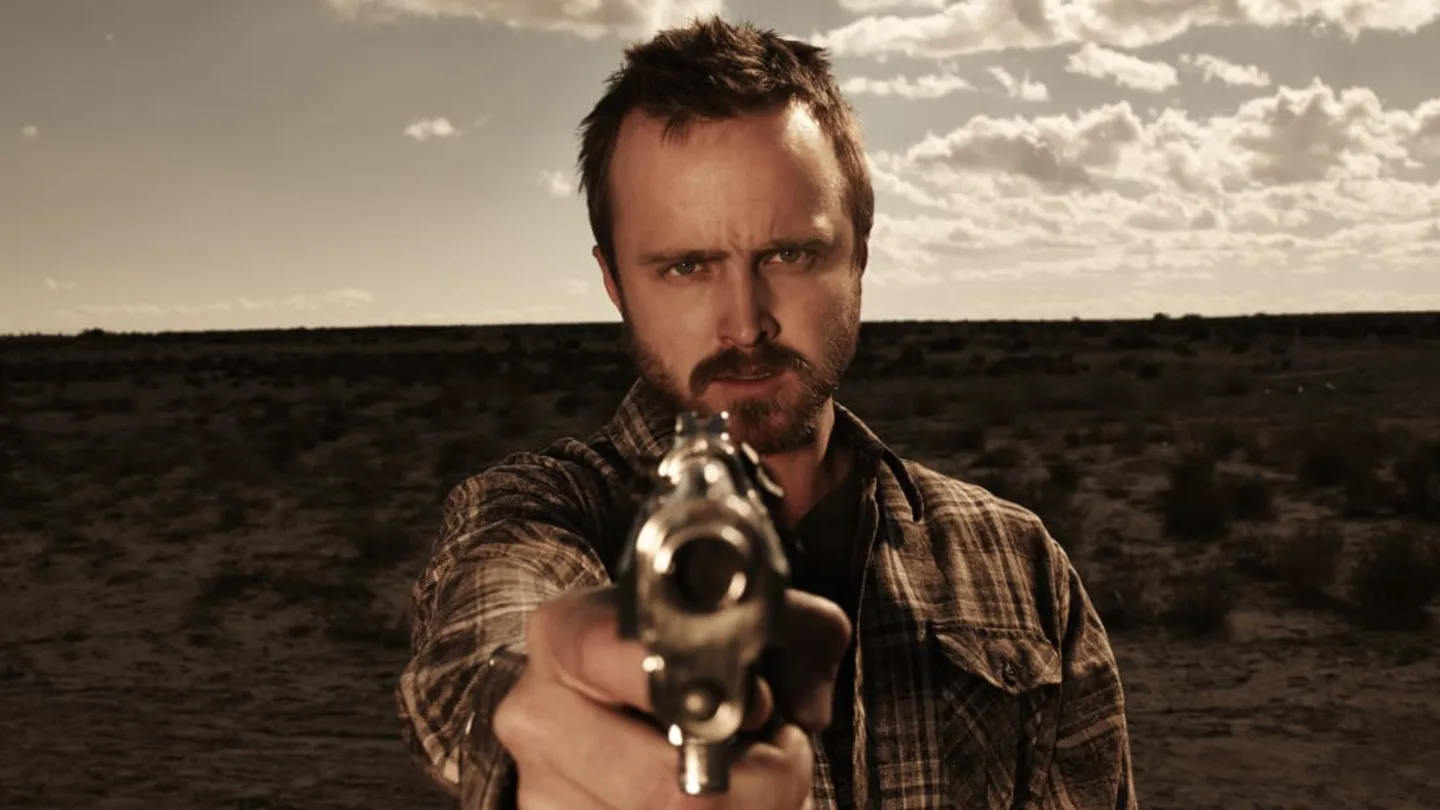What might be the significance of the desert setting in this image? The desert setting in the image might symbolize isolation, harshness, or abandonment, which aligns with the intense and possibly dangerous mood conveyed by the man holding the gun. This backdrop can also suggest a narrative of survival or conflict, emphasizing the lone figure’s confrontation with the viewer or an unseen opponent. 